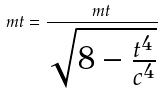<formula> <loc_0><loc_0><loc_500><loc_500>m t = \frac { m t } { \sqrt { 8 - \frac { t ^ { 4 } } { c ^ { 4 } } } }</formula> 